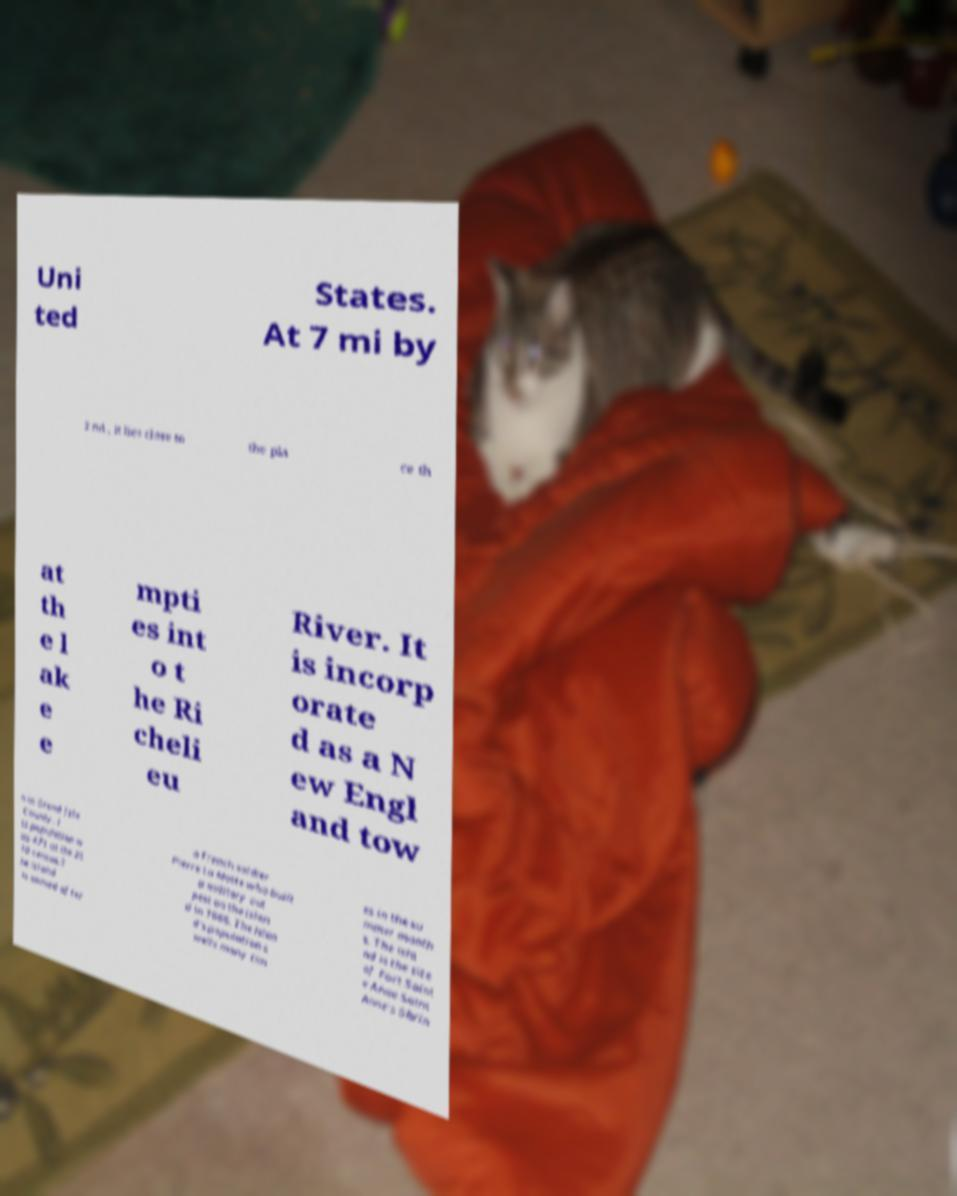Please read and relay the text visible in this image. What does it say? Uni ted States. At 7 mi by 2 mi , it lies close to the pla ce th at th e l ak e e mpti es int o t he Ri cheli eu River. It is incorp orate d as a N ew Engl and tow n in Grand Isle County. I ts population w as 471 at the 20 10 census.T he island is named after a French soldier Pierre La Motte who built a military out post on the islan d in 1666. The islan d's population s wells many tim es in the su mmer month s. The isla nd is the site of Fort Saint e Anne Saint Anne's Shrin 